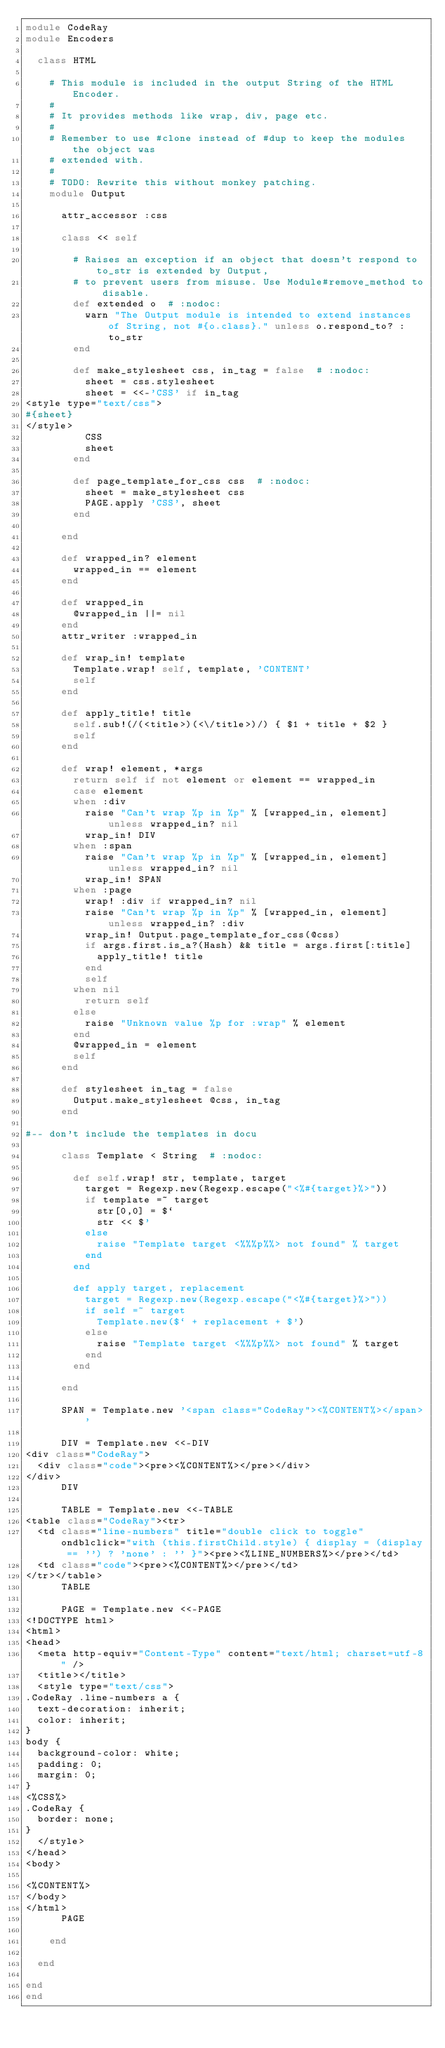Convert code to text. <code><loc_0><loc_0><loc_500><loc_500><_Ruby_>module CodeRay
module Encoders

  class HTML

    # This module is included in the output String of the HTML Encoder.
    #
    # It provides methods like wrap, div, page etc.
    #
    # Remember to use #clone instead of #dup to keep the modules the object was
    # extended with.
    #
    # TODO: Rewrite this without monkey patching.
    module Output

      attr_accessor :css

      class << self

        # Raises an exception if an object that doesn't respond to to_str is extended by Output,
        # to prevent users from misuse. Use Module#remove_method to disable.
        def extended o  # :nodoc:
          warn "The Output module is intended to extend instances of String, not #{o.class}." unless o.respond_to? :to_str
        end

        def make_stylesheet css, in_tag = false  # :nodoc:
          sheet = css.stylesheet
          sheet = <<-'CSS' if in_tag
<style type="text/css">
#{sheet}
</style>
          CSS
          sheet
        end

        def page_template_for_css css  # :nodoc:
          sheet = make_stylesheet css
          PAGE.apply 'CSS', sheet
        end

      end

      def wrapped_in? element
        wrapped_in == element
      end

      def wrapped_in
        @wrapped_in ||= nil
      end
      attr_writer :wrapped_in

      def wrap_in! template
        Template.wrap! self, template, 'CONTENT'
        self
      end
      
      def apply_title! title
        self.sub!(/(<title>)(<\/title>)/) { $1 + title + $2 }
        self
      end

      def wrap! element, *args
        return self if not element or element == wrapped_in
        case element
        when :div
          raise "Can't wrap %p in %p" % [wrapped_in, element] unless wrapped_in? nil
          wrap_in! DIV
        when :span
          raise "Can't wrap %p in %p" % [wrapped_in, element] unless wrapped_in? nil
          wrap_in! SPAN
        when :page
          wrap! :div if wrapped_in? nil
          raise "Can't wrap %p in %p" % [wrapped_in, element] unless wrapped_in? :div
          wrap_in! Output.page_template_for_css(@css)
          if args.first.is_a?(Hash) && title = args.first[:title]
            apply_title! title
          end
          self
        when nil
          return self
        else
          raise "Unknown value %p for :wrap" % element
        end
        @wrapped_in = element
        self
      end

      def stylesheet in_tag = false
        Output.make_stylesheet @css, in_tag
      end

#-- don't include the templates in docu

      class Template < String  # :nodoc:

        def self.wrap! str, template, target
          target = Regexp.new(Regexp.escape("<%#{target}%>"))
          if template =~ target
            str[0,0] = $`
            str << $'
          else
            raise "Template target <%%%p%%> not found" % target
          end
        end

        def apply target, replacement
          target = Regexp.new(Regexp.escape("<%#{target}%>"))
          if self =~ target
            Template.new($` + replacement + $')
          else
            raise "Template target <%%%p%%> not found" % target
          end
        end

      end

      SPAN = Template.new '<span class="CodeRay"><%CONTENT%></span>'

      DIV = Template.new <<-DIV
<div class="CodeRay">
  <div class="code"><pre><%CONTENT%></pre></div>
</div>
      DIV

      TABLE = Template.new <<-TABLE
<table class="CodeRay"><tr>
  <td class="line-numbers" title="double click to toggle" ondblclick="with (this.firstChild.style) { display = (display == '') ? 'none' : '' }"><pre><%LINE_NUMBERS%></pre></td>
  <td class="code"><pre><%CONTENT%></pre></td>
</tr></table>
      TABLE

      PAGE = Template.new <<-PAGE
<!DOCTYPE html>
<html>
<head>
  <meta http-equiv="Content-Type" content="text/html; charset=utf-8" />
  <title></title>
  <style type="text/css">
.CodeRay .line-numbers a {
  text-decoration: inherit;
  color: inherit;
}
body {
  background-color: white;
  padding: 0;
  margin: 0;
}
<%CSS%>
.CodeRay {
  border: none;
}
  </style>
</head>
<body>

<%CONTENT%>
</body>
</html>
      PAGE

    end

  end

end
end
</code> 